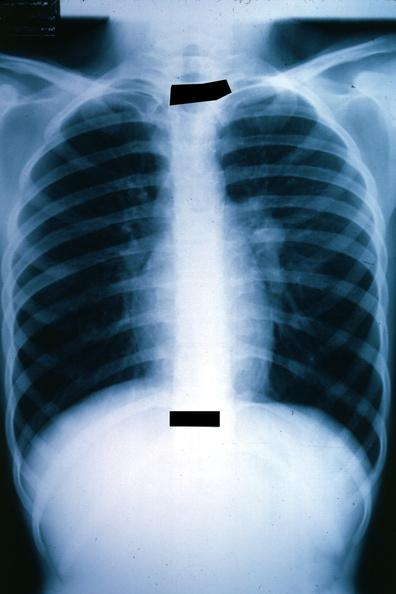where is this?
Answer the question using a single word or phrase. Lung 